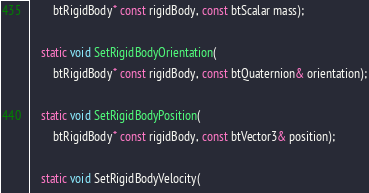<code> <loc_0><loc_0><loc_500><loc_500><_C_>        btRigidBody* const rigidBody, const btScalar mass);

    static void SetRigidBodyOrientation(
        btRigidBody* const rigidBody, const btQuaternion& orientation);

    static void SetRigidBodyPosition(
        btRigidBody* const rigidBody, const btVector3& position);

    static void SetRigidBodyVelocity(</code> 